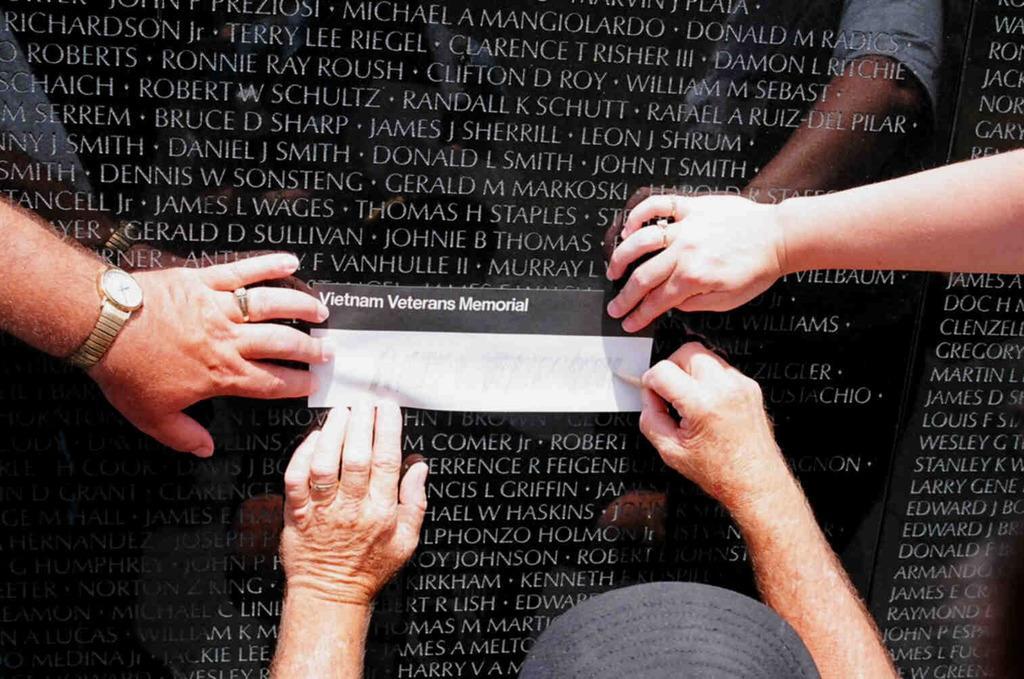Please provide a concise description of this image. In this picture we can see a memorial in the background, there are four hands and a paper present on the memorial. 